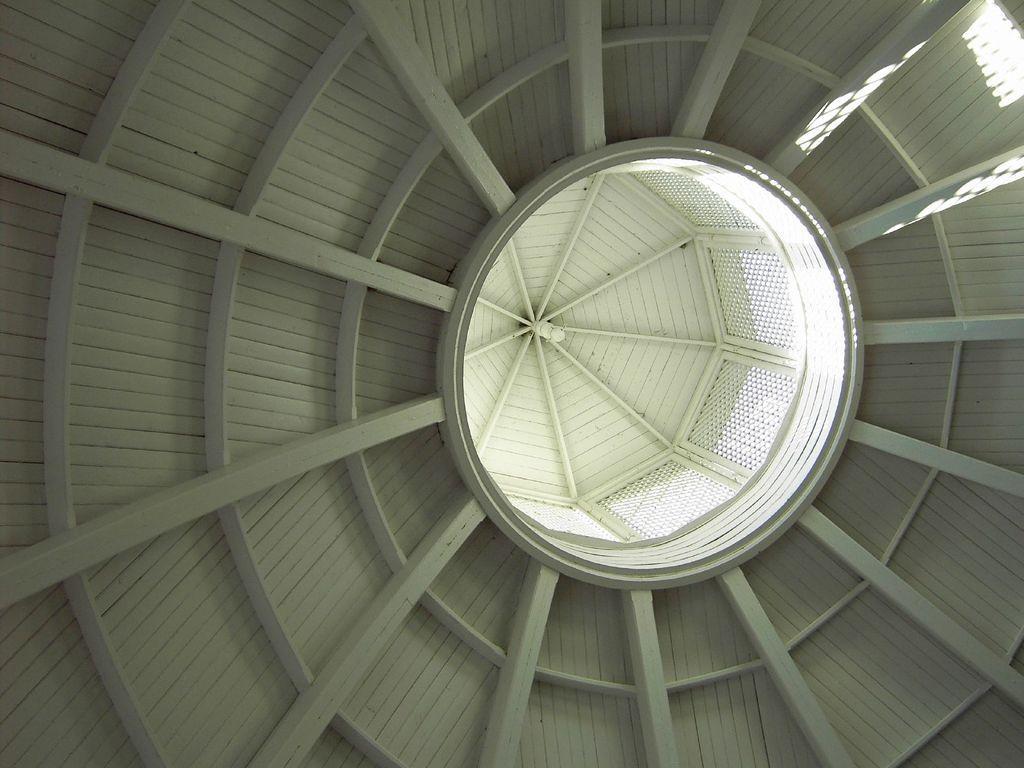Can you describe this image briefly? This picture is consists of a roof in the image. 